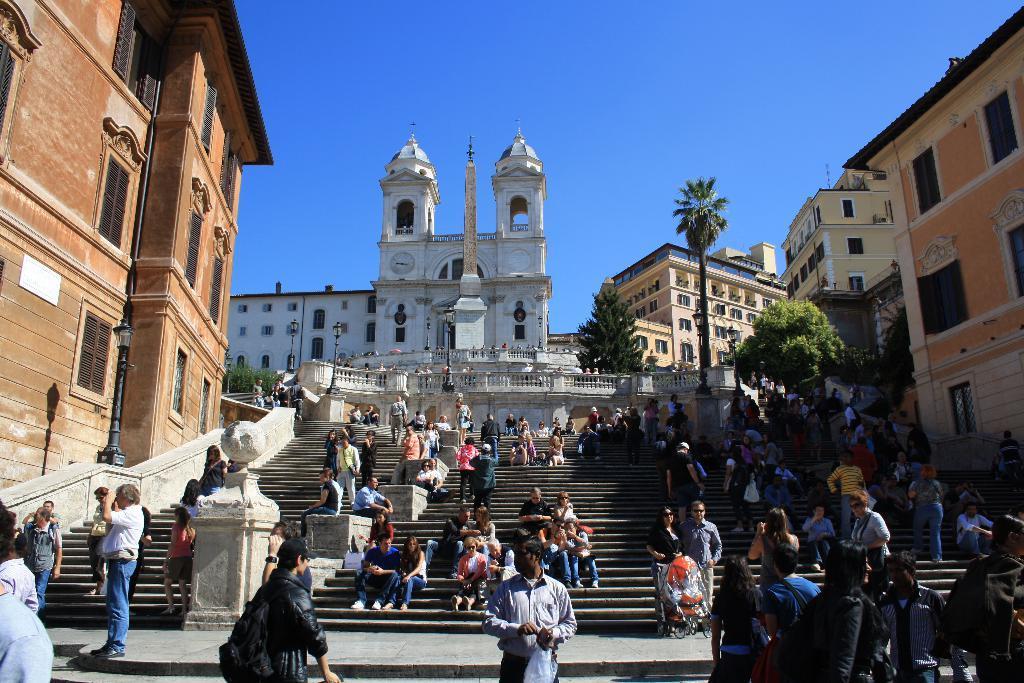Could you give a brief overview of what you see in this image? In this image we can see many people. There are few people sitting on staircases and few people are standing in the image. There are few people holding some objects in their hands. There are few staircases in the image. There are few trees in the image. There are many buildings in the image. 